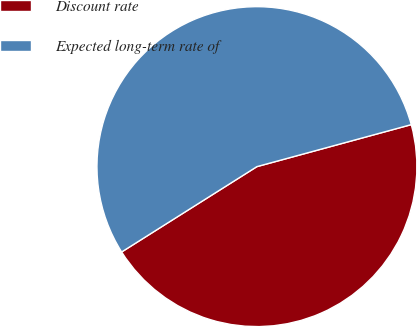Convert chart. <chart><loc_0><loc_0><loc_500><loc_500><pie_chart><fcel>Discount rate<fcel>Expected long-term rate of<nl><fcel>45.27%<fcel>54.73%<nl></chart> 